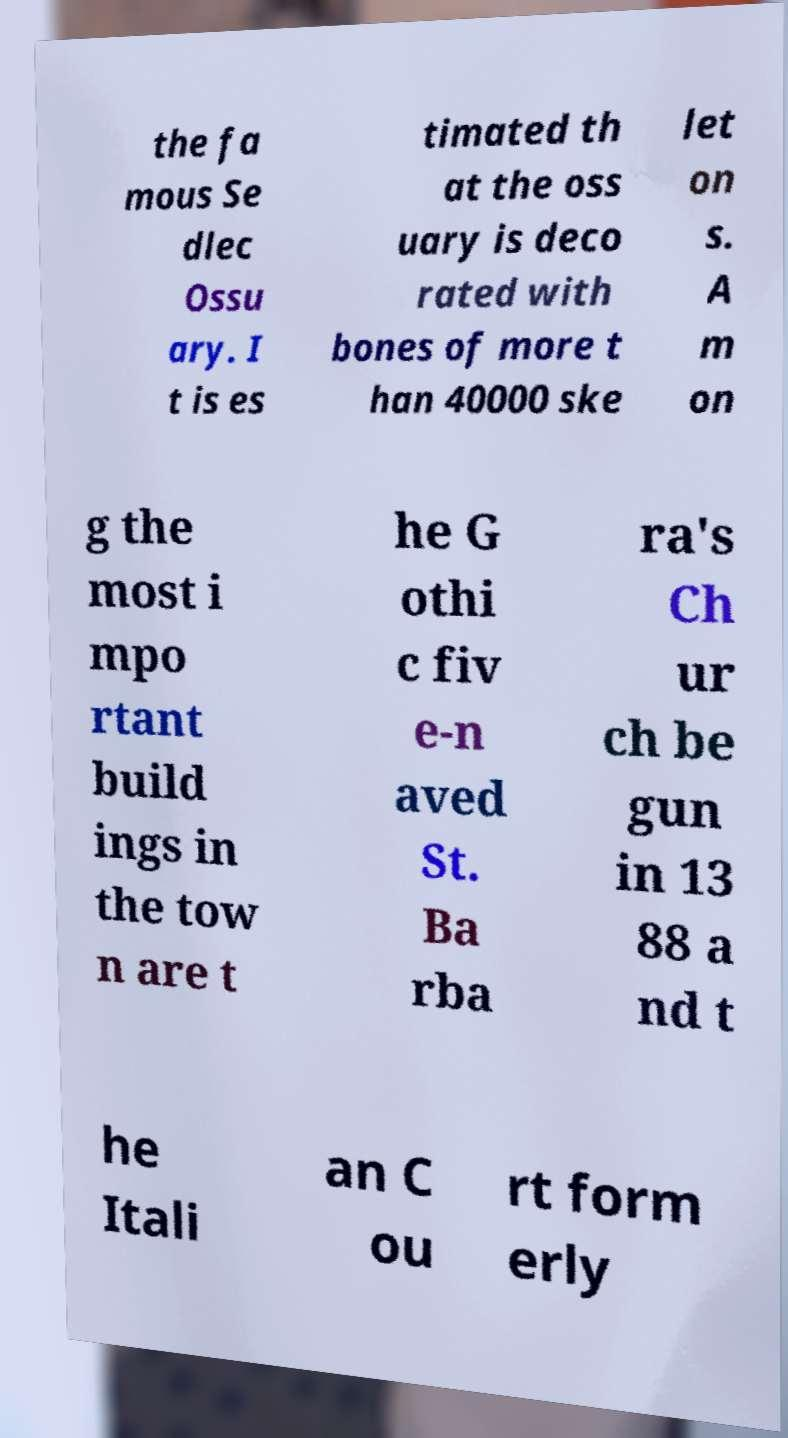Could you assist in decoding the text presented in this image and type it out clearly? the fa mous Se dlec Ossu ary. I t is es timated th at the oss uary is deco rated with bones of more t han 40000 ske let on s. A m on g the most i mpo rtant build ings in the tow n are t he G othi c fiv e-n aved St. Ba rba ra's Ch ur ch be gun in 13 88 a nd t he Itali an C ou rt form erly 